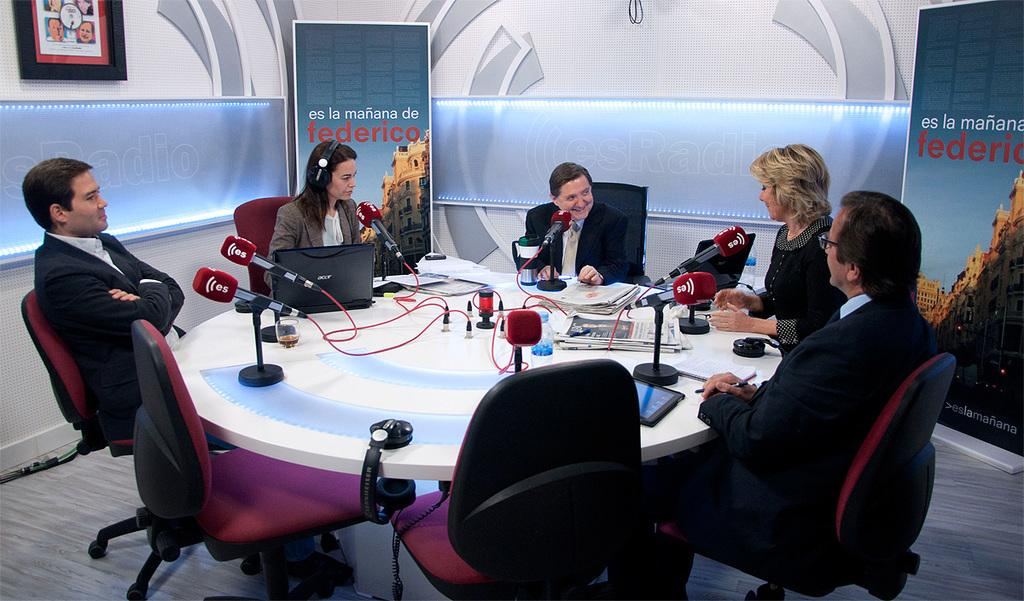What is the arrangement of people in the image? People are seated on chairs around a table. What objects are on the table? There are microphones and papers on the table. What can be seen on the banners in the image? The banners have "Federico" written on them. What type of kite is being flown by the person in the image? There is no kite present in the image; people are seated around a table with microphones and papers. Can you tell me how many bats are hanging from the ceiling in the image? There are no bats present in the image; the only banners have "Federico" written on them. 